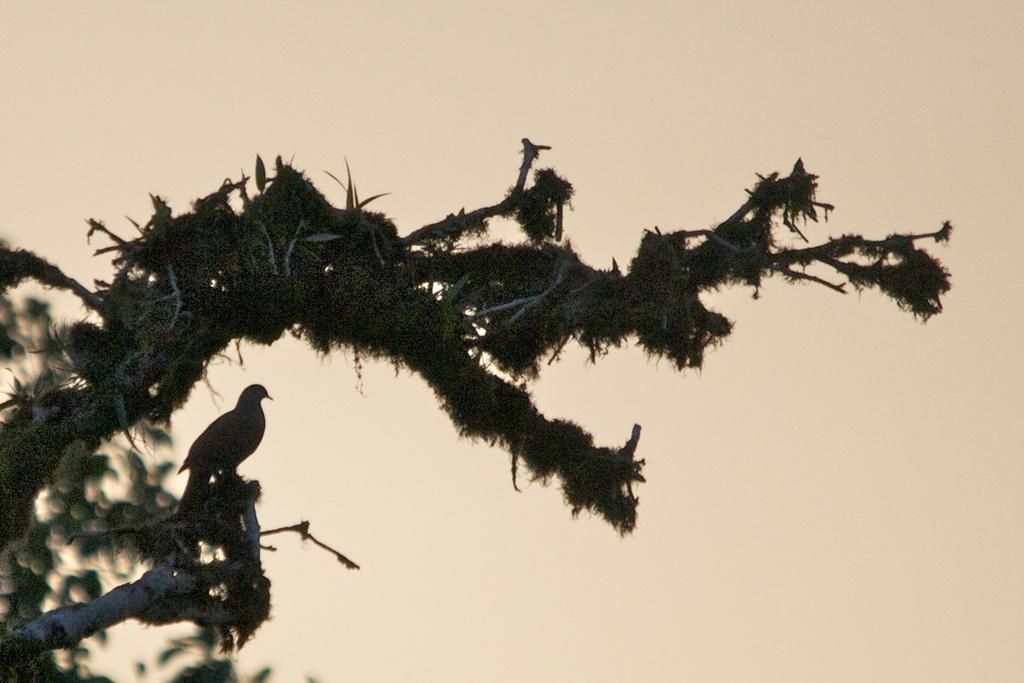In one or two sentences, can you explain what this image depicts? On the right side of the image we can see a bird is present on the tree. In the background of the image we can see the sky. 